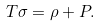Convert formula to latex. <formula><loc_0><loc_0><loc_500><loc_500>T \sigma = \rho + P .</formula> 